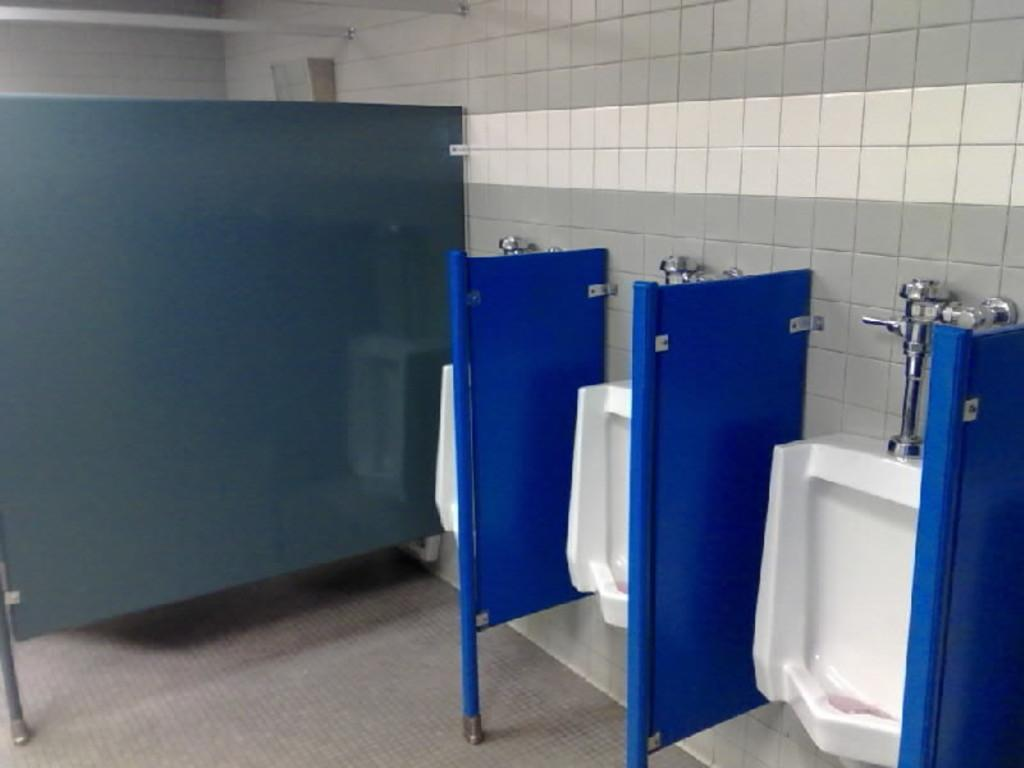What type of furniture is present in the image? There are toilet commodes in the image. What other objects can be seen in the image? There are boards and rods visible in the image. What is the background of the image made of? There is a wall in the image. What is the surface that the toilet commodes and boards are placed on? There is a floor in the image. How does the hen feel about the presence of the giraffe in the image? There is no hen or giraffe present in the image, so this question cannot be answered. 